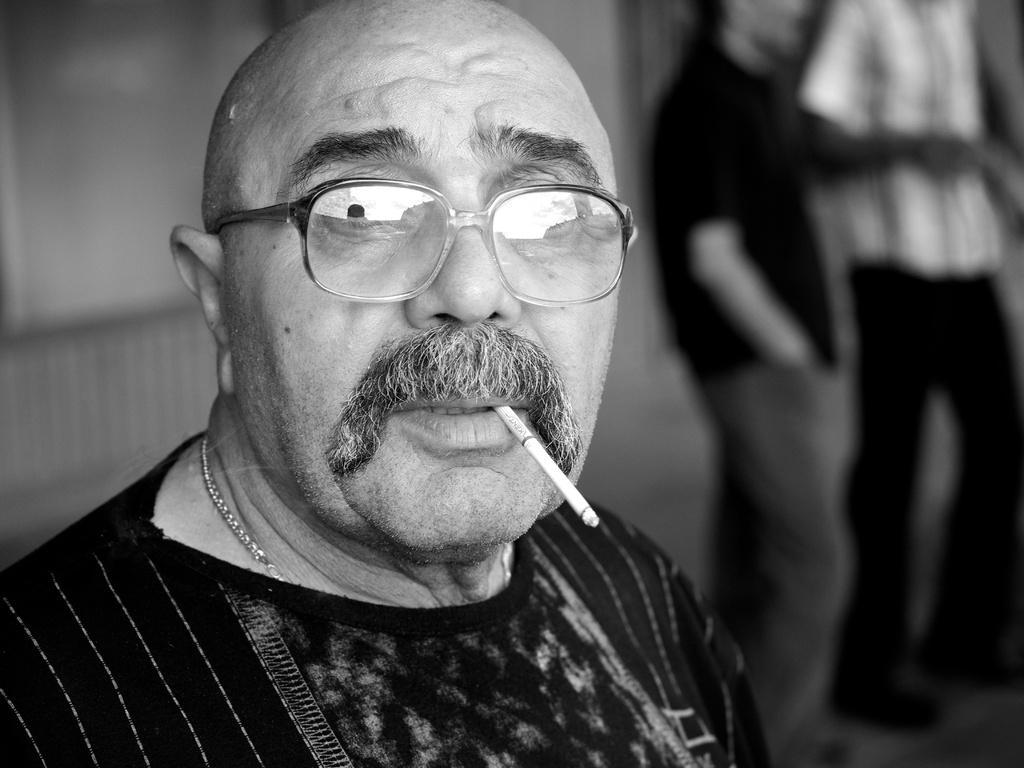What is the color scheme of the image? The image is black and white. Who is the main subject in the image? There is a man in the image. What is the man wearing in the image? The man is wearing glasses. What is the man holding in his mouth? The man has a cigarette in his mouth. How is the background of the image depicted? The background of the image is blurred. Can you describe the other people in the image? There are two other persons in the background. What type of dog can be seen observing the man in the image? There is no dog present in the image; it only features a man and two other persons in the background. What kind of lumber is being used to build the structure in the image? There is no structure or lumber visible in the image; it is a black and white image of a man with a blurred background. 